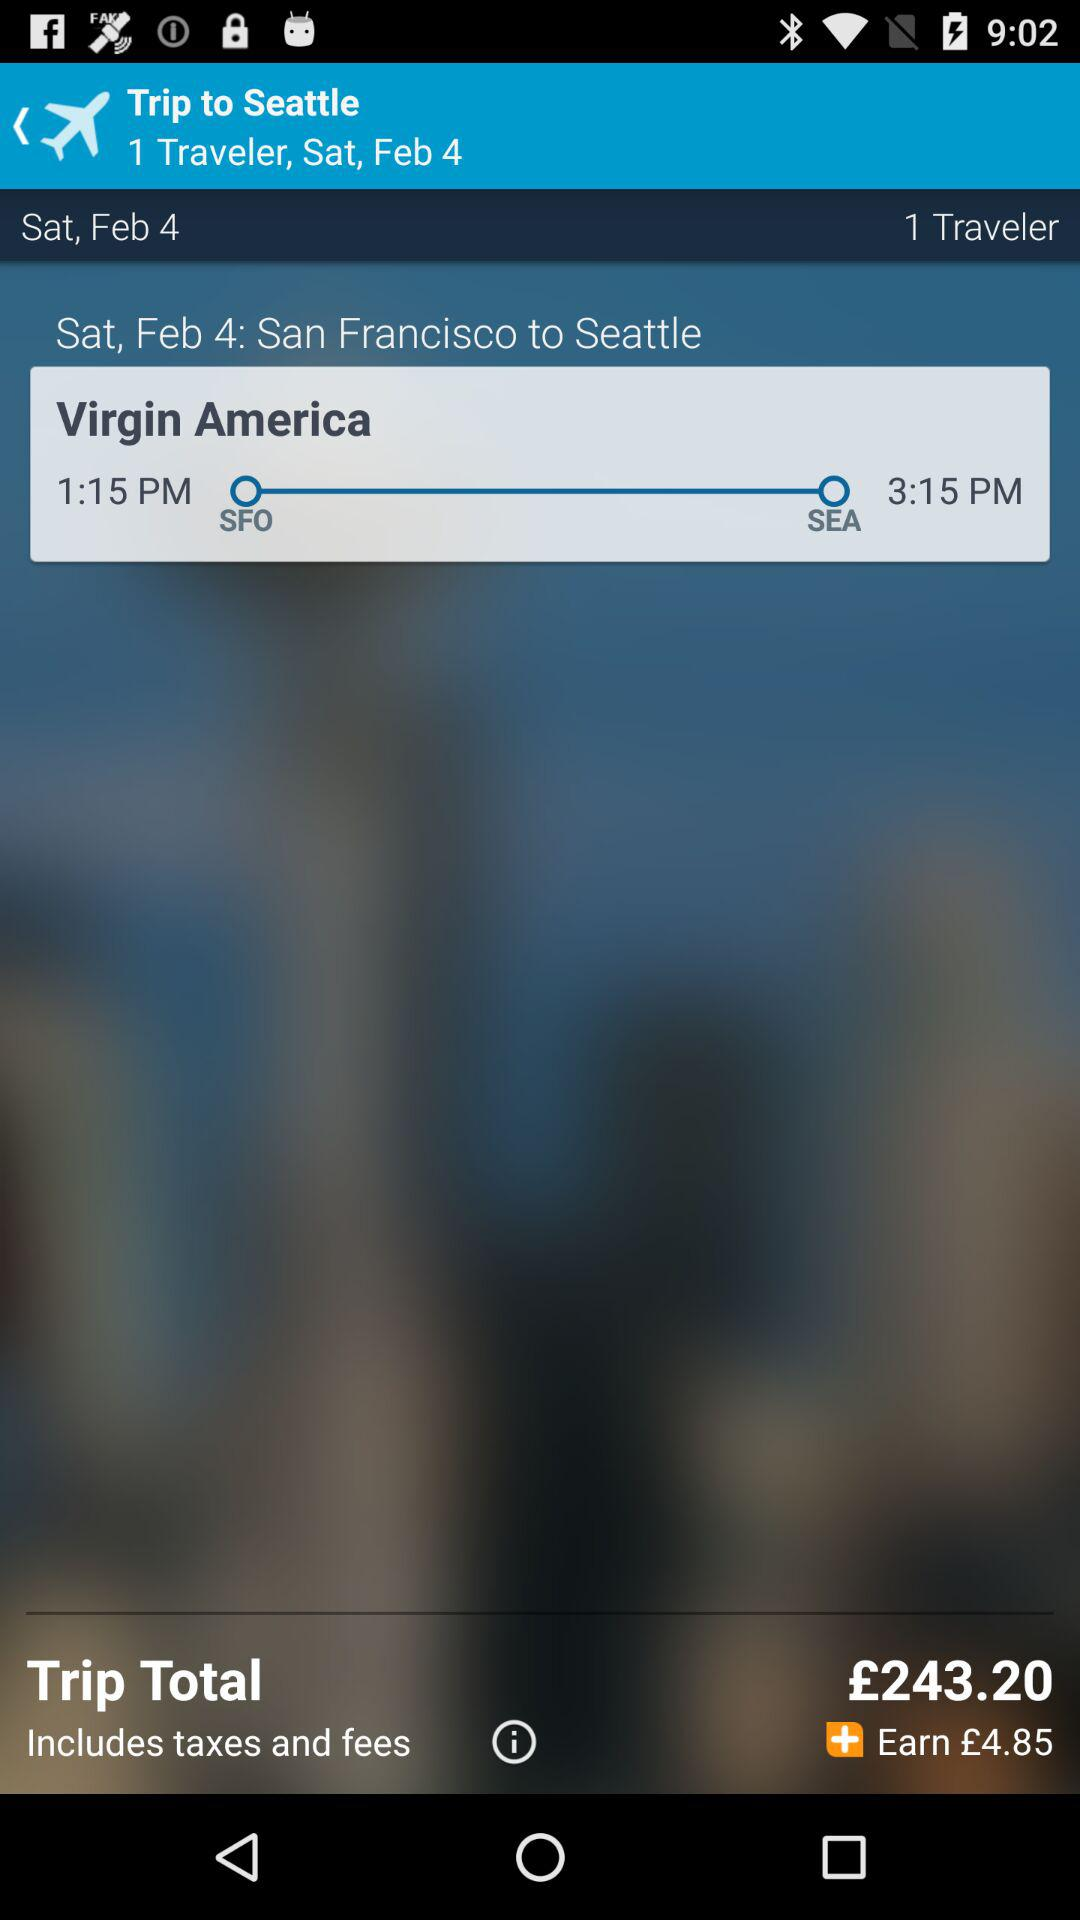What is the total amount? The total amount is £243.20. 